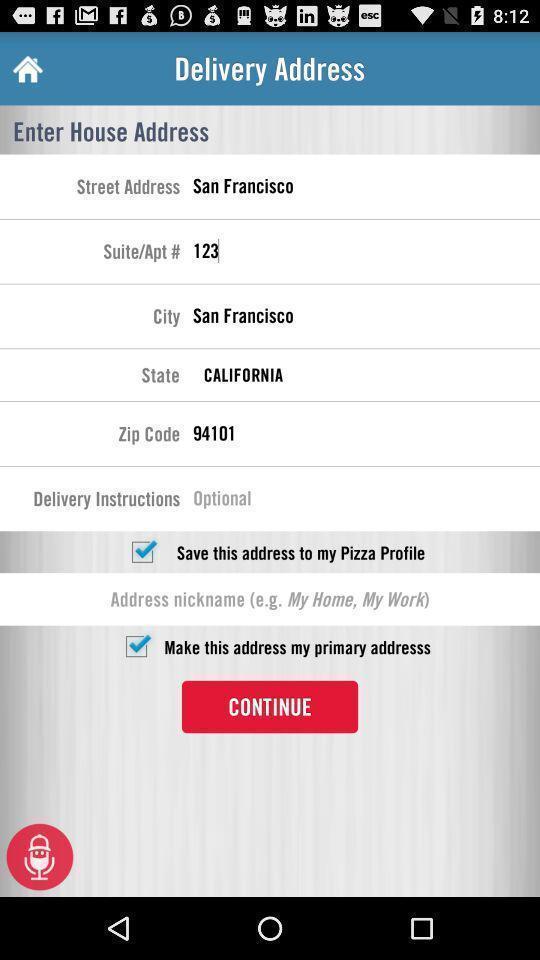Tell me what you see in this picture. Screen displaying address editing page. 